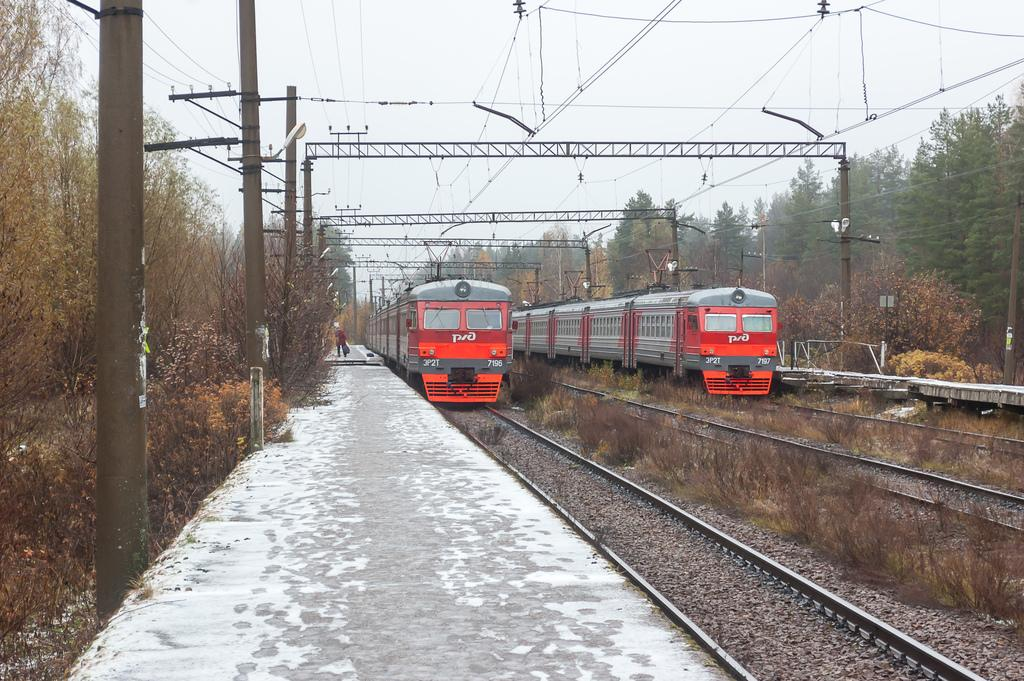What can be seen on the track in the image? There are two trains on the track in the image. What is present on the track besides the trains? There are pebbles on the track. What can be seen on both sides of the image? There are poles and trees on both sides of the image. How would you describe the sky in the image? The sky is clear in the image. What type of ear is visible on the train in the image? There are no ears visible on the train in the image, as trains do not have ears. 